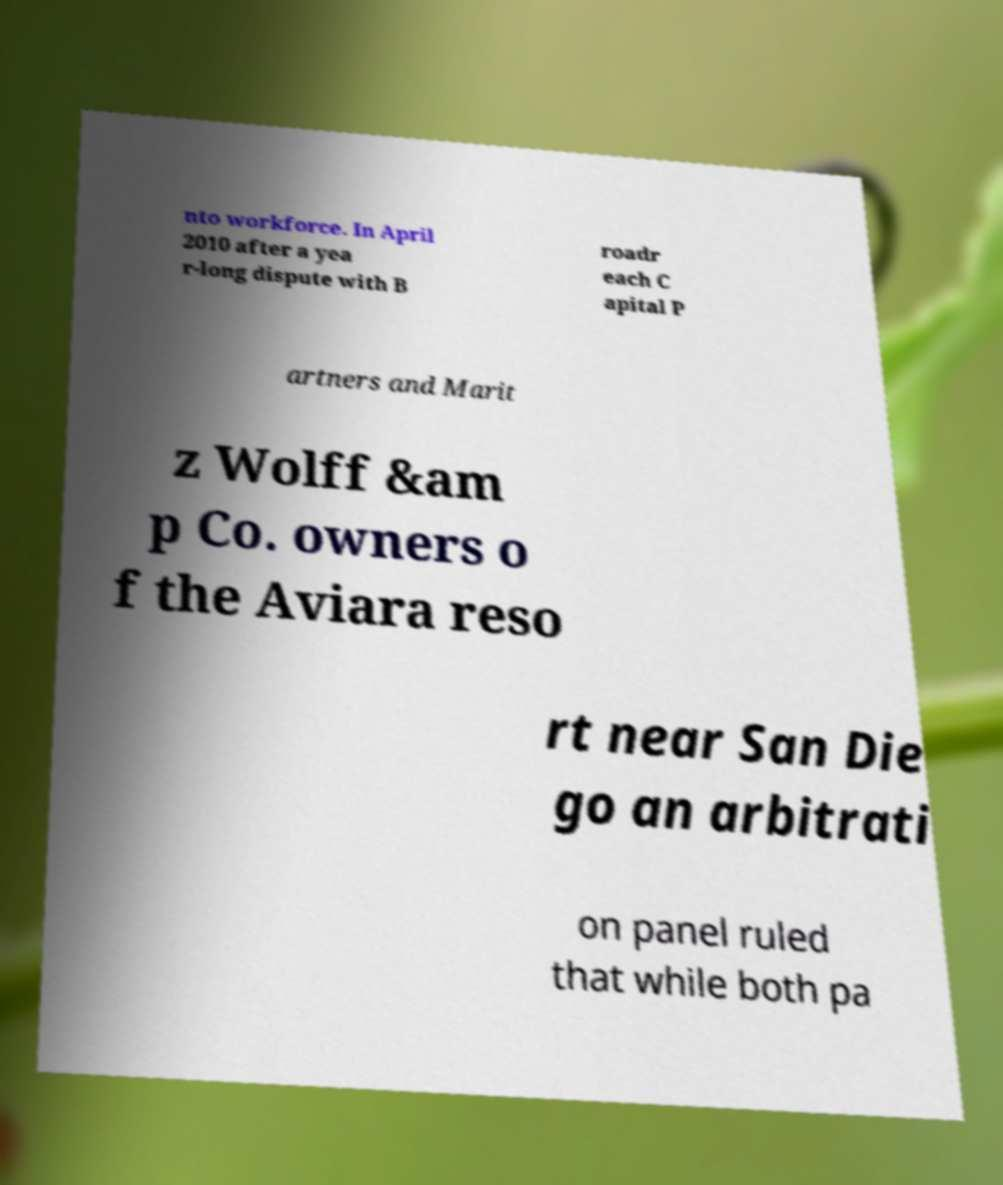What messages or text are displayed in this image? I need them in a readable, typed format. nto workforce. In April 2010 after a yea r-long dispute with B roadr each C apital P artners and Marit z Wolff &am p Co. owners o f the Aviara reso rt near San Die go an arbitrati on panel ruled that while both pa 